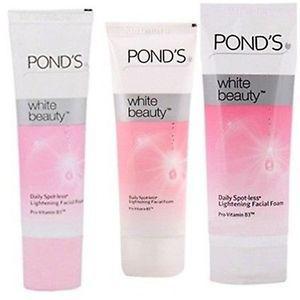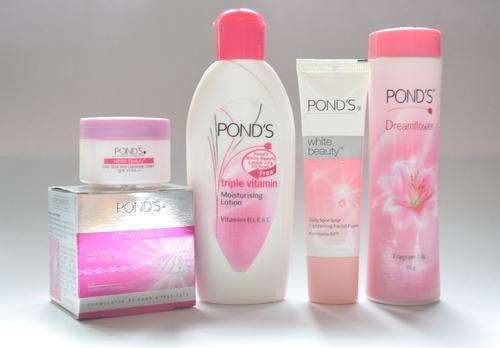The first image is the image on the left, the second image is the image on the right. For the images shown, is this caption "There are not more than two different products and they are all made by Ponds." true? Answer yes or no. No. 